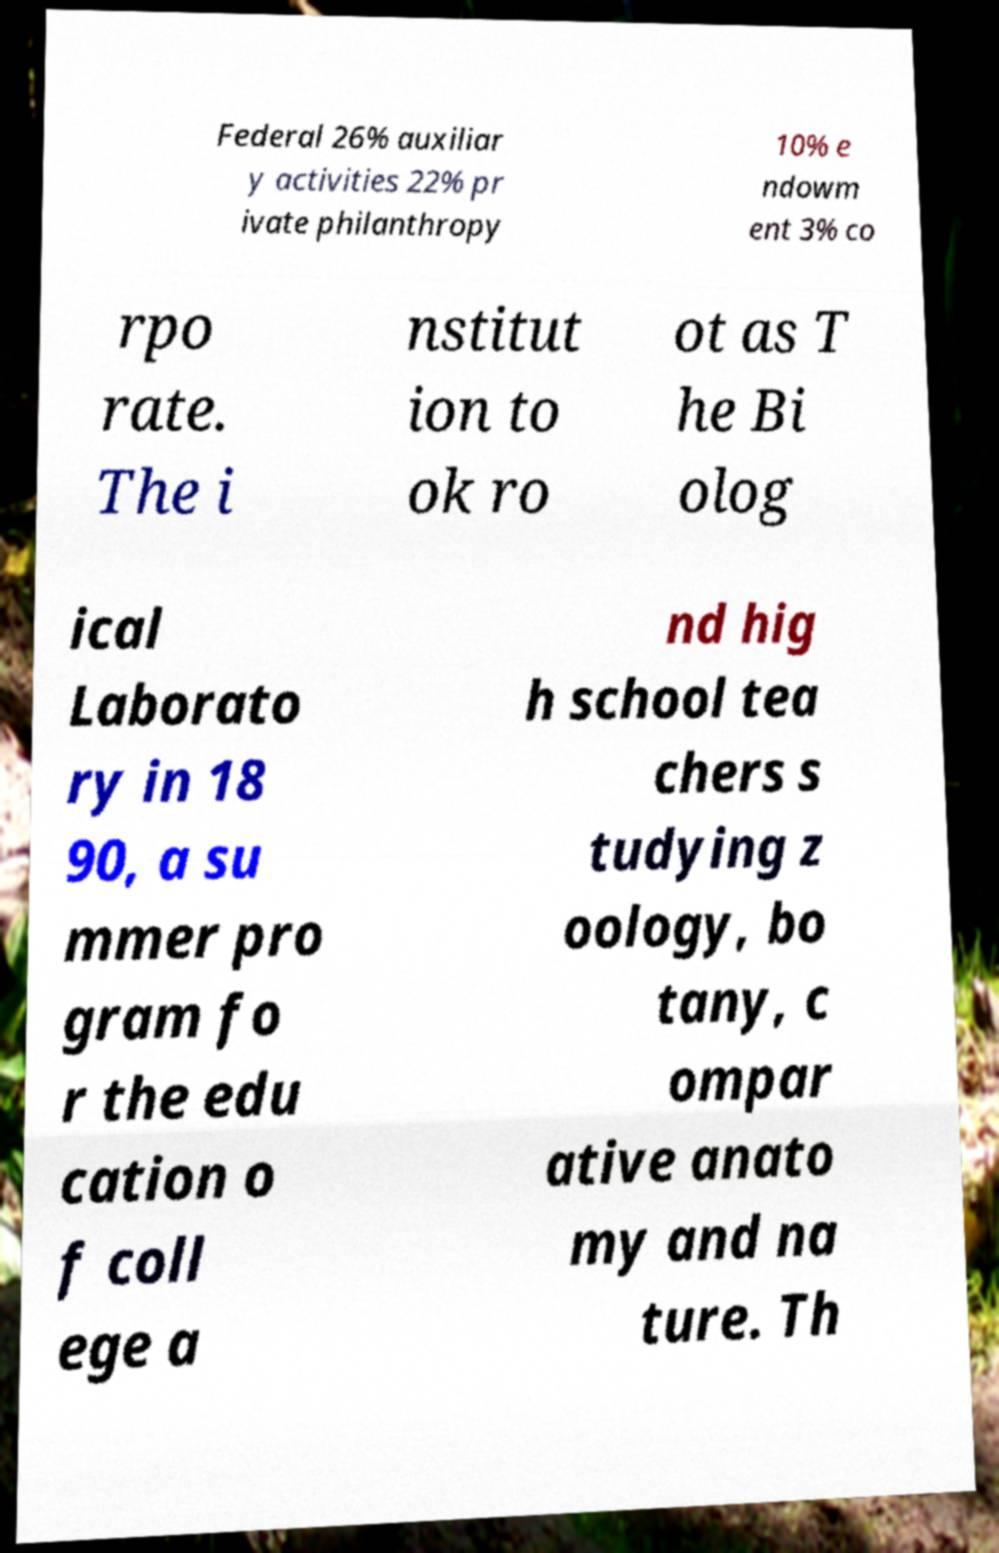Can you accurately transcribe the text from the provided image for me? Federal 26% auxiliar y activities 22% pr ivate philanthropy 10% e ndowm ent 3% co rpo rate. The i nstitut ion to ok ro ot as T he Bi olog ical Laborato ry in 18 90, a su mmer pro gram fo r the edu cation o f coll ege a nd hig h school tea chers s tudying z oology, bo tany, c ompar ative anato my and na ture. Th 